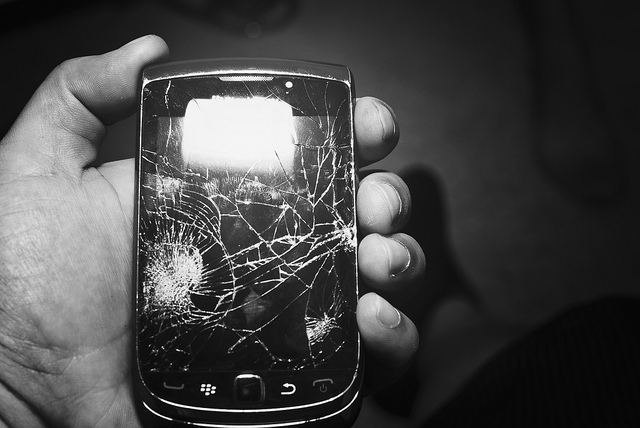What might have caused the damage visible on the phone's screen? The damage to the screen, characterized by significant cracking, likely resulted from a forceful impact. This could be from dropping the phone onto a hard surface or it being struck with a heavy object. Such damage impairs usability and may affect the display and touch functionality. Is this type of damage reparable? It is possible to repair a cracked screen like the one shown, although the feasibility and cost depend on the model and availability of replacement parts. For older models like this Blackberry, finding the necessary parts may be more challenging and possibly not cost-effective compared to replacing the device. 